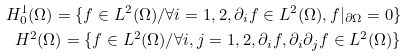Convert formula to latex. <formula><loc_0><loc_0><loc_500><loc_500>H ^ { 1 } _ { 0 } ( \Omega ) = \{ f \in L ^ { 2 } ( \Omega ) / \forall i = 1 , 2 , \partial _ { i } f \in L ^ { 2 } ( \Omega ) , f | _ { \partial \Omega } = 0 \} \\ H ^ { 2 } ( \Omega ) = \{ f \in L ^ { 2 } ( \Omega ) / \forall i , j = 1 , 2 , \partial _ { i } f , \partial _ { i } \partial _ { j } f \in L ^ { 2 } ( \Omega ) \}</formula> 